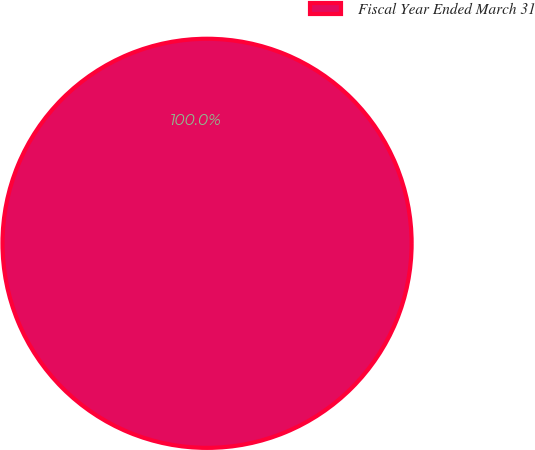<chart> <loc_0><loc_0><loc_500><loc_500><pie_chart><fcel>Fiscal Year Ended March 31<nl><fcel>100.0%<nl></chart> 